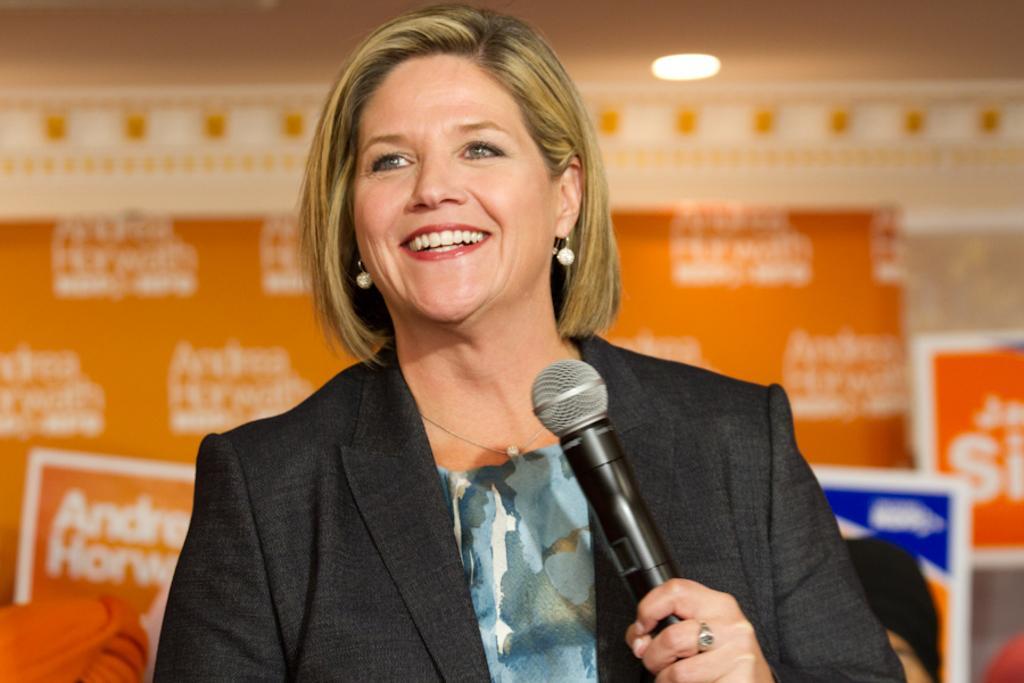Could you give a brief overview of what you see in this image? In this image there is a lady person wearing a black color suit holding a microphone in her left hand. 